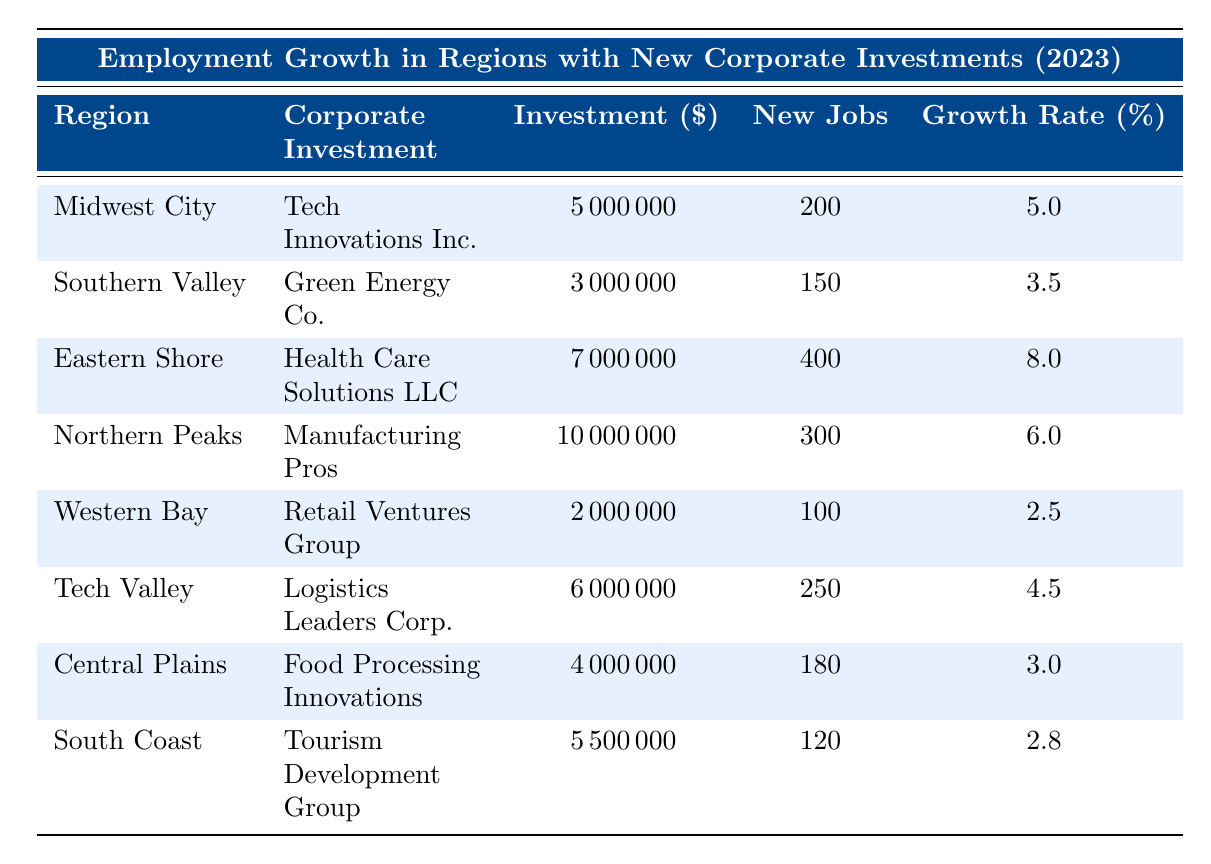What is the corporate investment amount in Eastern Shore? The table shows that the corporate investment amount for Eastern Shore is listed as 7000000.
Answer: 7000000 Which region created the highest number of new jobs? By examining the "New Jobs" column, Eastern Shore shows the highest number of new jobs created at 400.
Answer: Eastern Shore What is the total investment amount in the Southern Valley and Western Bay regions? The investment amounts are 3000000 for Southern Valley and 2000000 for Western Bay. Adding these gives 3000000 + 2000000 = 5000000.
Answer: 5000000 Is the employment growth rate in Central Plains greater than 4%? The table lists the employment growth rate for Central Plains as 3.0%, which is less than 4%.
Answer: No What is the average employment growth rate across all regions? To find the average, add all the growth rates: 5 + 3.5 + 8 + 6 + 2.5 + 4.5 + 3 + 2.8 = 36.3. There are 8 regions, so divide by 8 to get an average of 36.3 / 8 = 4.5375, which rounds to 4.54.
Answer: 4.54 Which region received the lowest amount of corporate investment? The lowest investment amount in the table is 2000000, which corresponds to the Western Bay region.
Answer: Western Bay Compare the employment growth rates of Tech Valley and Northern Peaks. Which region has a higher rate? Tech Valley has an employment growth rate of 4.5%, while Northern Peaks has a rate of 6.0%. Therefore, Northern Peaks has a higher rate.
Answer: Northern Peaks If the investment amount for Manufacturing Pros increased by 25%, what would the new amount be? The current investment for Manufacturing Pros is 10000000. To find the increment, calculate 25% of 10000000, which is 10000000 * 0.25 = 2500000. The new amount is 10000000 + 2500000 = 12500000.
Answer: 12500000 